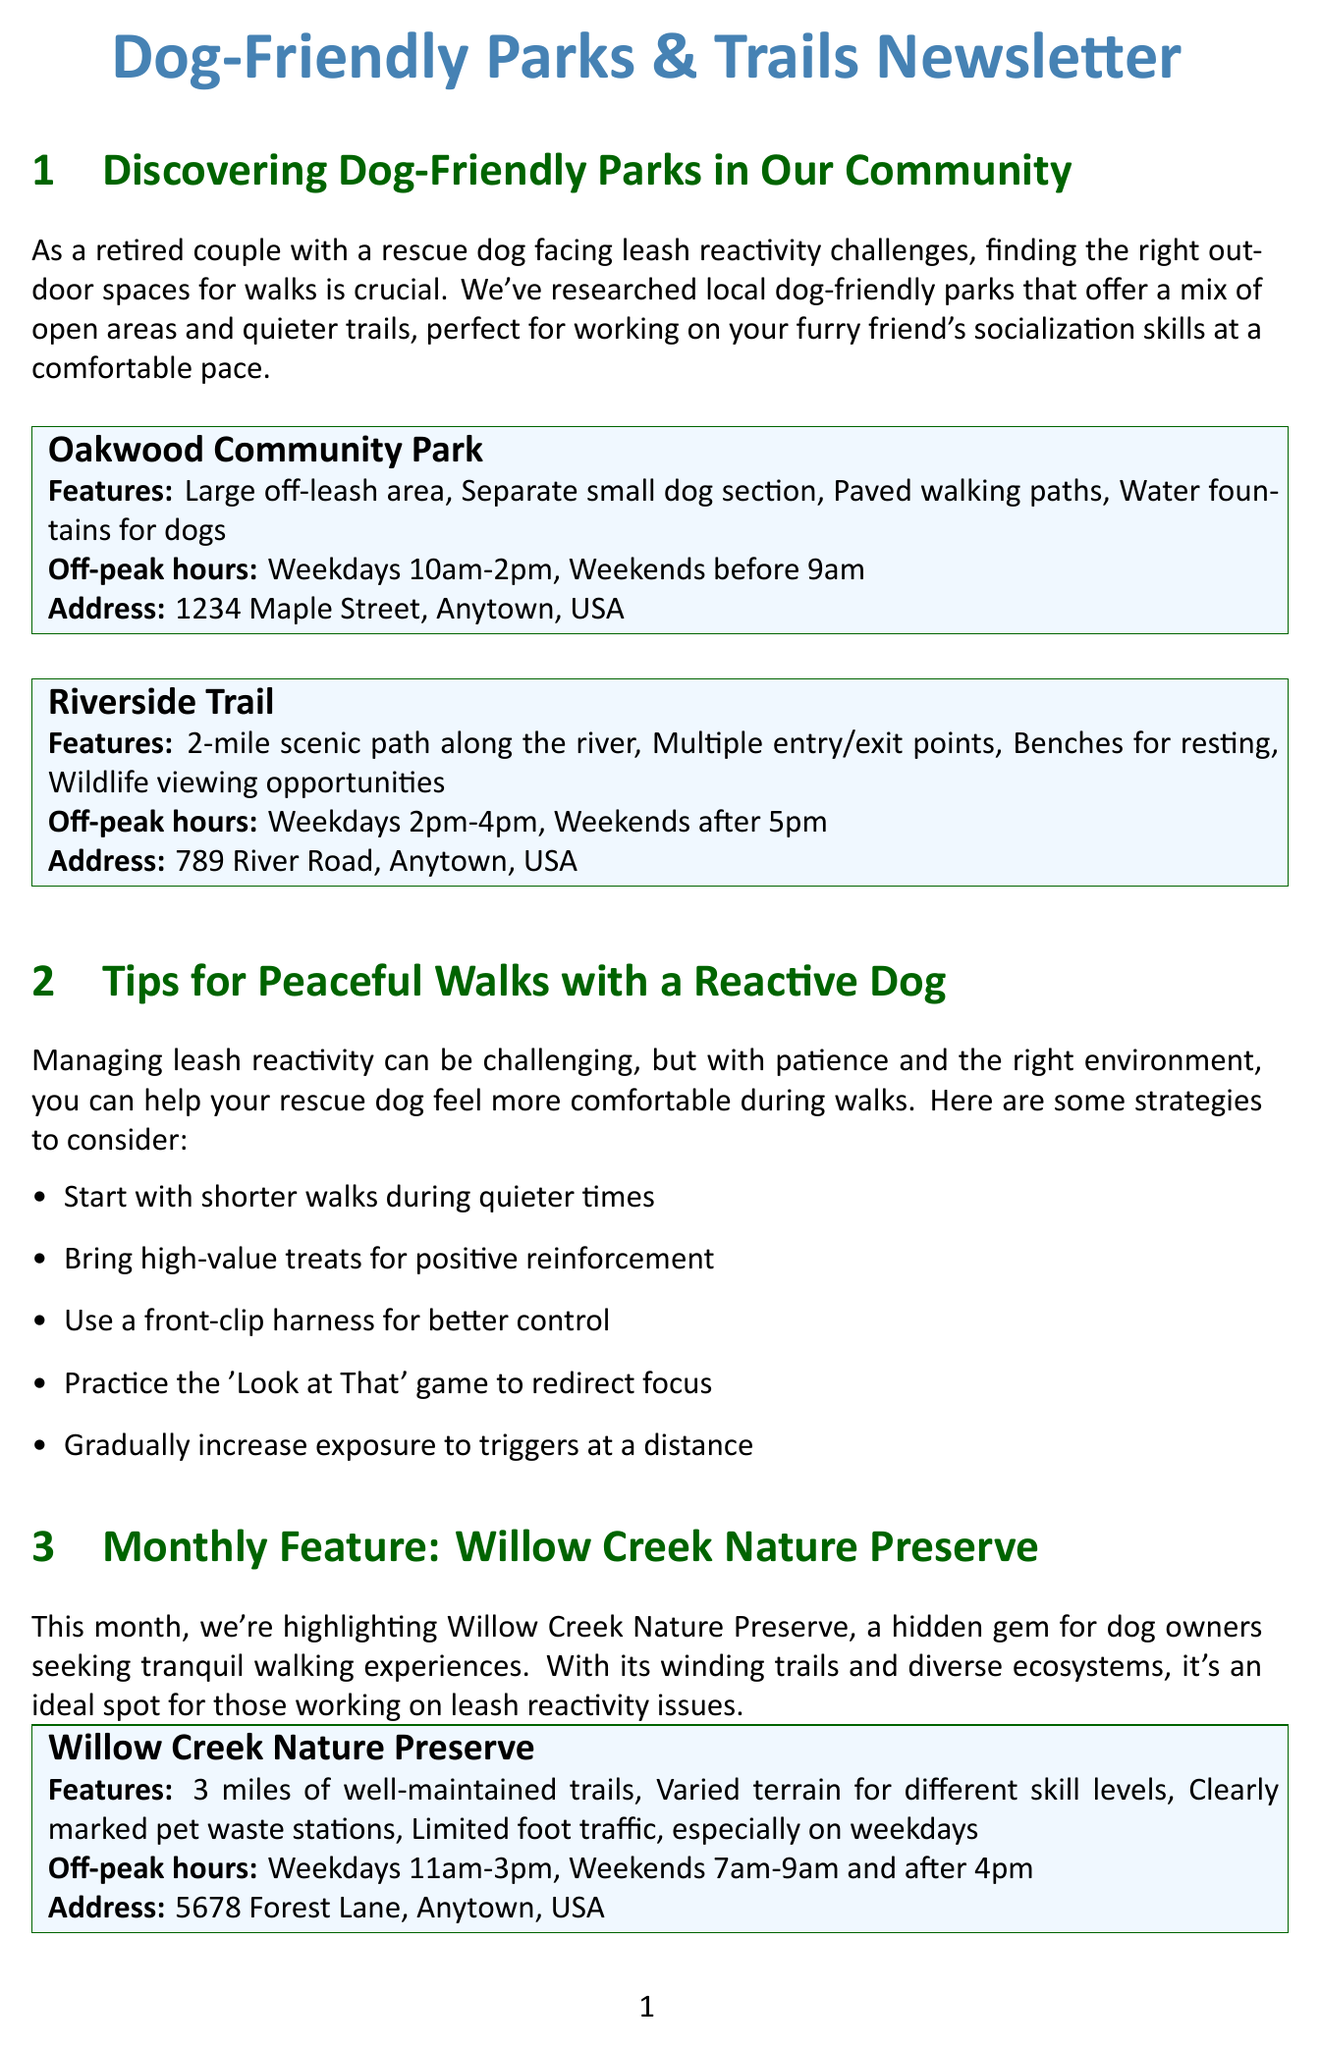What is the name of the park with a large off-leash area? The park with a large off-leash area is Oakwood Community Park, as mentioned in the document.
Answer: Oakwood Community Park What are the off-peak hours for the Riverside Trail? The off-peak hours for the Riverside Trail are specified in the document as weekdays 2pm-4pm and weekends after 5pm.
Answer: Weekdays 2pm-4pm, Weekends after 5pm How long is the scenic path along the river? The scenic path along the river is detailed in the document as a 2-mile path.
Answer: 2-mile What is the purpose of the Leash Reactivity Support Group? The purpose of the Leash Reactivity Support Group is to connect dog owners facing similar challenges regarding leash reactivity, based on the document's content.
Answer: Connect dog owners What is the main feature highlighted for this month's park? The document highlights winding trails and diverse ecosystems as the main feature of Willow Creek Nature Preserve this month.
Answer: Winding trails and diverse ecosystems What is the contact person's name for the support group? The document provides the name of the contact person for the support group as John Smith.
Answer: John Smith How many miles of trails are available at Willow Creek Nature Preserve? According to the document, Willow Creek Nature Preserve has 3 miles of well-maintained trails available for walking.
Answer: 3 miles When is the monthly meeting for the Leash Reactivity Support Group? The document specifies that the monthly meeting for the Leash Reactivity Support Group is on the first Tuesday of every month.
Answer: First Tuesday of every month What is the address of Oakwood Community Park? The address of Oakwood Community Park is provided in the document as 1234 Maple Street, Anytown, USA.
Answer: 1234 Maple Street, Anytown, USA 